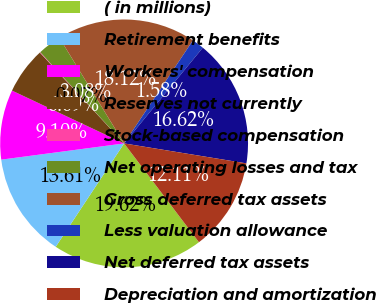Convert chart. <chart><loc_0><loc_0><loc_500><loc_500><pie_chart><fcel>( in millions)<fcel>Retirement benefits<fcel>Workers' compensation<fcel>Reserves not currently<fcel>Stock-based compensation<fcel>Net operating losses and tax<fcel>Gross deferred tax assets<fcel>Less valuation allowance<fcel>Net deferred tax assets<fcel>Depreciation and amortization<nl><fcel>19.62%<fcel>13.61%<fcel>9.1%<fcel>6.09%<fcel>0.07%<fcel>3.08%<fcel>18.12%<fcel>1.58%<fcel>16.62%<fcel>12.11%<nl></chart> 